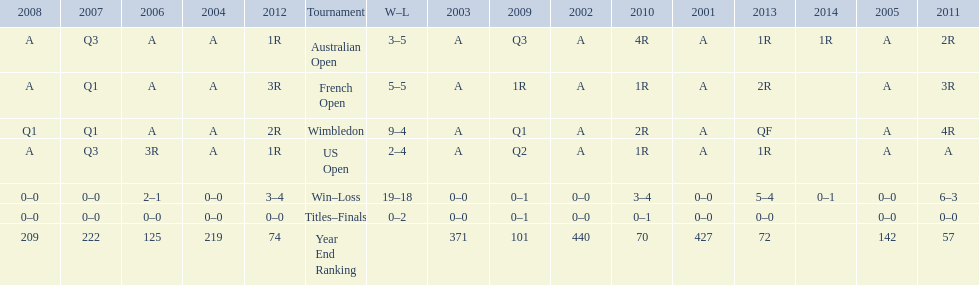In which years were there only 1 loss? 2006, 2009, 2014. 